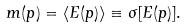Convert formula to latex. <formula><loc_0><loc_0><loc_500><loc_500>m ( p ) = \langle E ( p ) \rangle \equiv \sigma [ E ( p ) ] .</formula> 